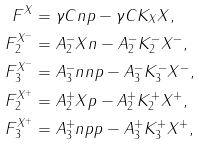<formula> <loc_0><loc_0><loc_500><loc_500>F ^ { X } & = \gamma C n p - \gamma C K _ { X } X , \\ F _ { 2 } ^ { X ^ { - } } & = A _ { 2 } ^ { - } X n - A _ { 2 } ^ { - } K _ { 2 } ^ { - } X ^ { - } , \\ F _ { 3 } ^ { X ^ { - } } & = A _ { 3 } ^ { - } n n p - A _ { 3 } ^ { - } K _ { 3 } ^ { - } X ^ { - } , \\ F _ { 2 } ^ { X ^ { + } } & = A _ { 2 } ^ { + } X p - A _ { 2 } ^ { + } K _ { 2 } ^ { + } X ^ { + } , \\ F _ { 3 } ^ { X ^ { + } } & = A _ { 3 } ^ { + } n p p - A _ { 3 } ^ { + } K _ { 3 } ^ { + } X ^ { + } ,</formula> 